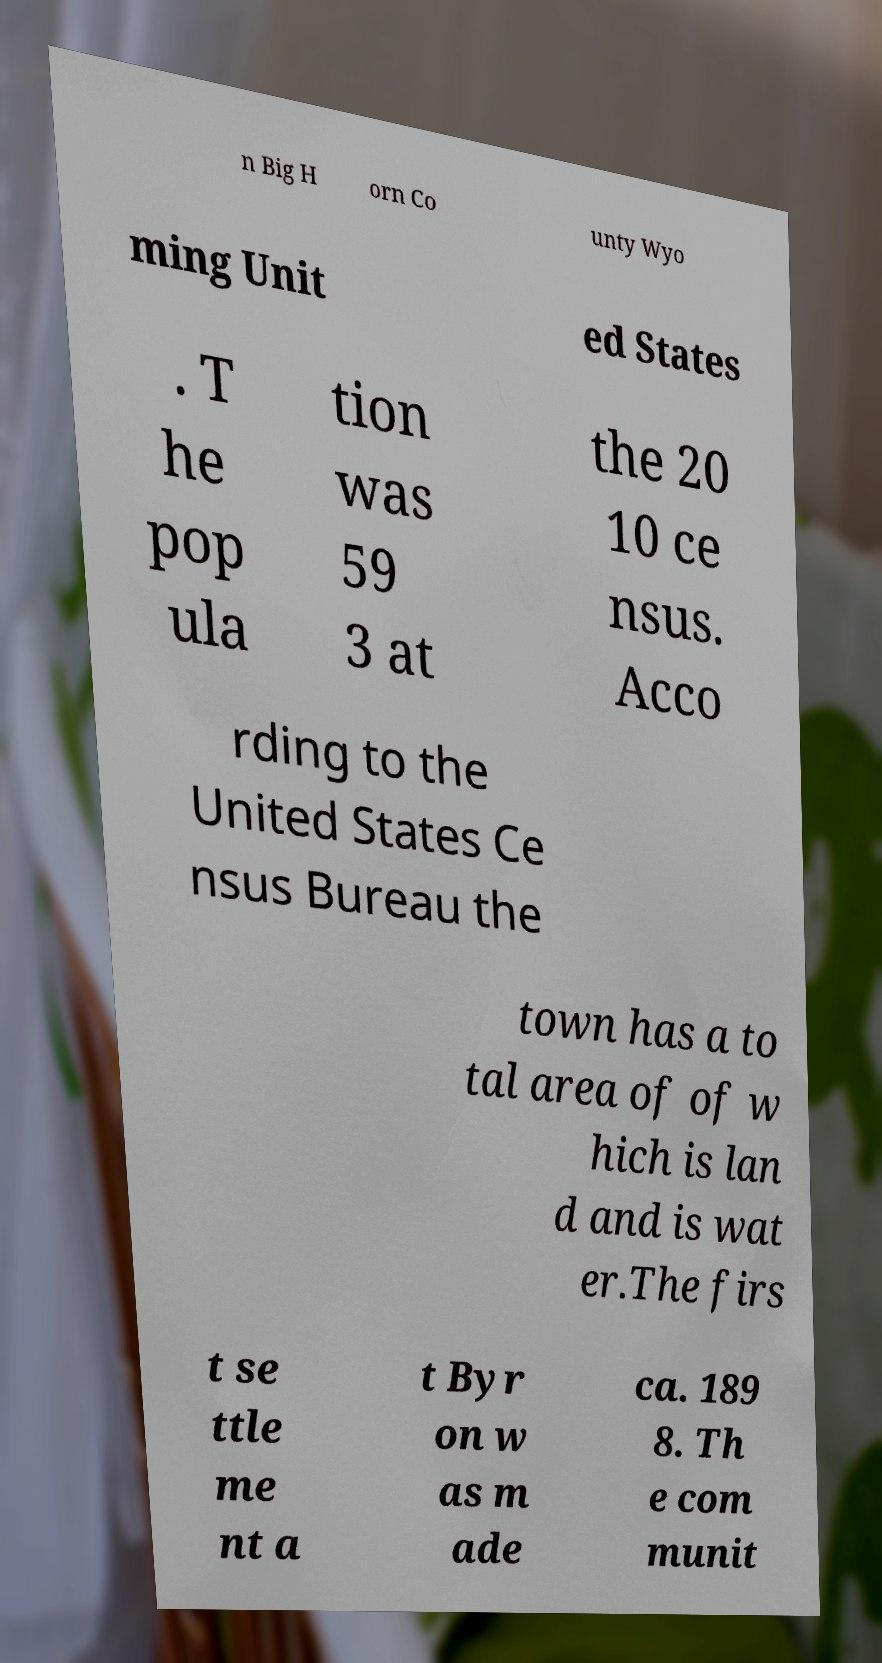There's text embedded in this image that I need extracted. Can you transcribe it verbatim? n Big H orn Co unty Wyo ming Unit ed States . T he pop ula tion was 59 3 at the 20 10 ce nsus. Acco rding to the United States Ce nsus Bureau the town has a to tal area of of w hich is lan d and is wat er.The firs t se ttle me nt a t Byr on w as m ade ca. 189 8. Th e com munit 